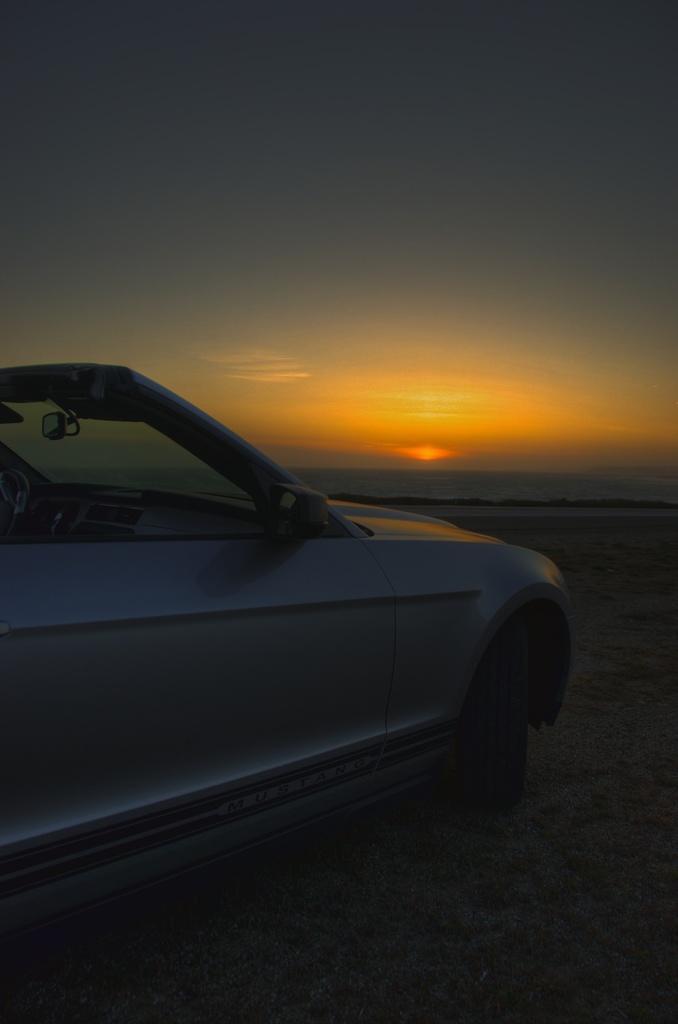In one or two sentences, can you explain what this image depicts? In this image I can see the vehicle on the sand. In the background I can see the water, sun, and the sky. 